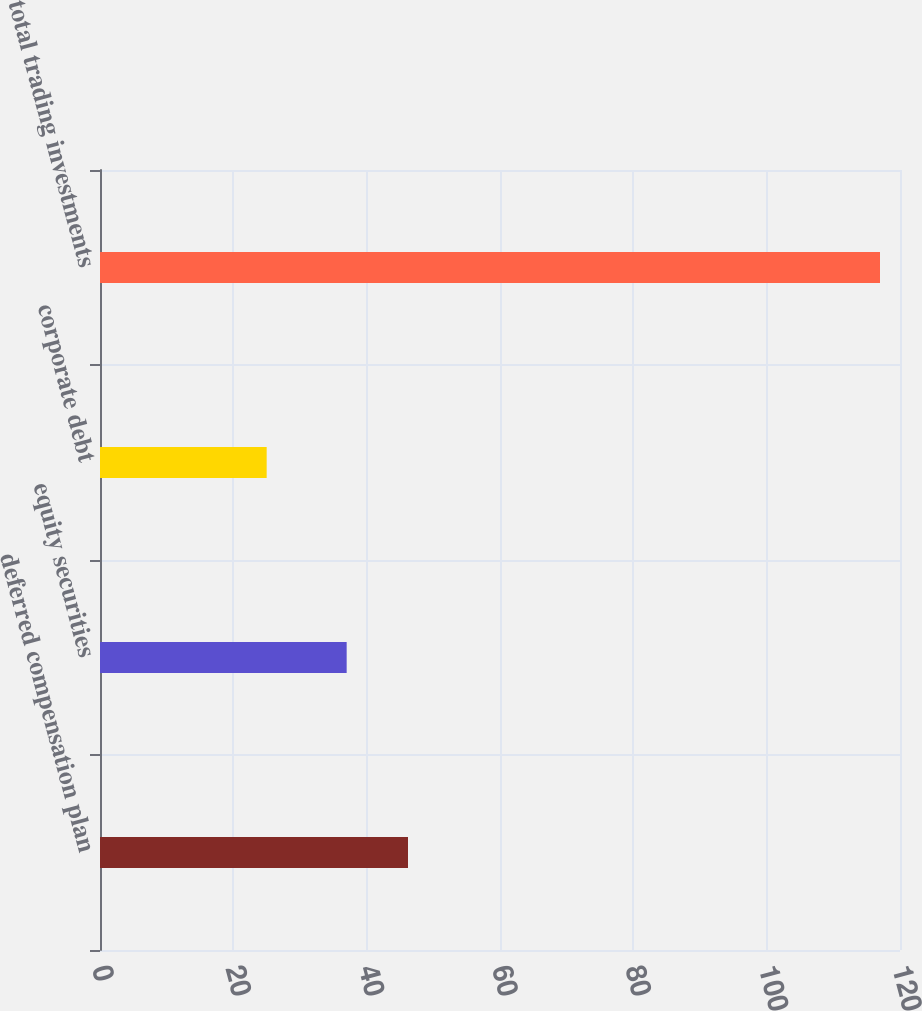Convert chart to OTSL. <chart><loc_0><loc_0><loc_500><loc_500><bar_chart><fcel>deferred compensation plan<fcel>equity securities<fcel>corporate debt<fcel>total trading investments<nl><fcel>46.2<fcel>37<fcel>25<fcel>117<nl></chart> 